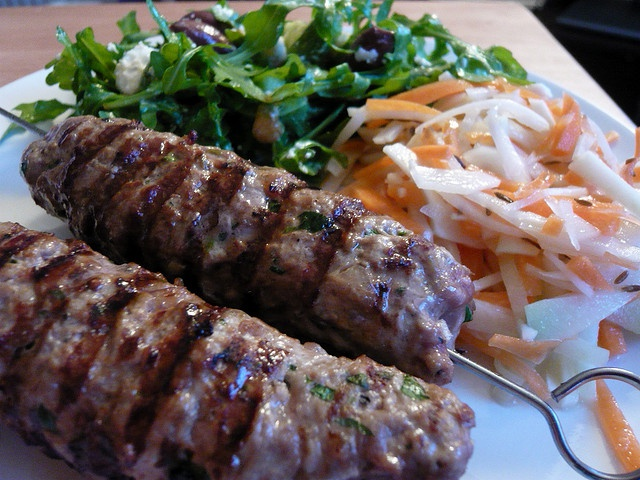Describe the objects in this image and their specific colors. I can see dining table in blue, lightgray, darkgray, and gray tones, carrot in blue, maroon, and brown tones, carrot in blue, salmon, tan, and lightpink tones, carrot in blue, salmon, and lightpink tones, and carrot in blue, lightpink, tan, red, and salmon tones in this image. 